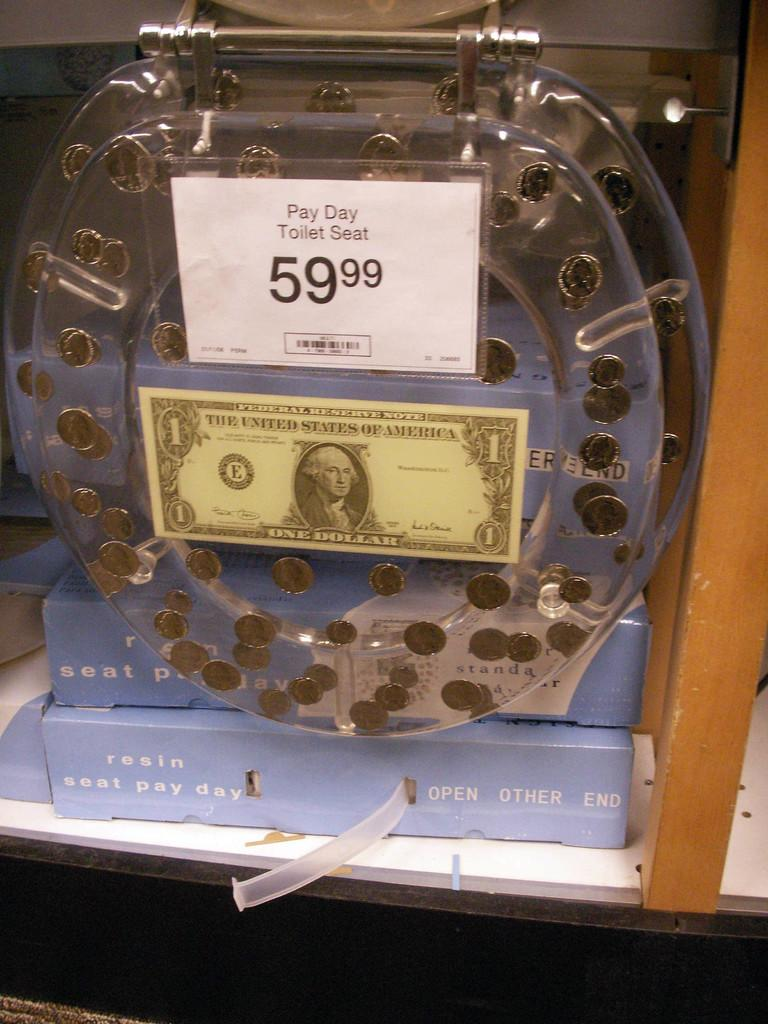<image>
Share a concise interpretation of the image provided. A toilet seat is priced at 59.99 and has a dollar bill on it. 